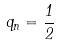Convert formula to latex. <formula><loc_0><loc_0><loc_500><loc_500>q _ { n } = \frac { 1 } { 2 }</formula> 